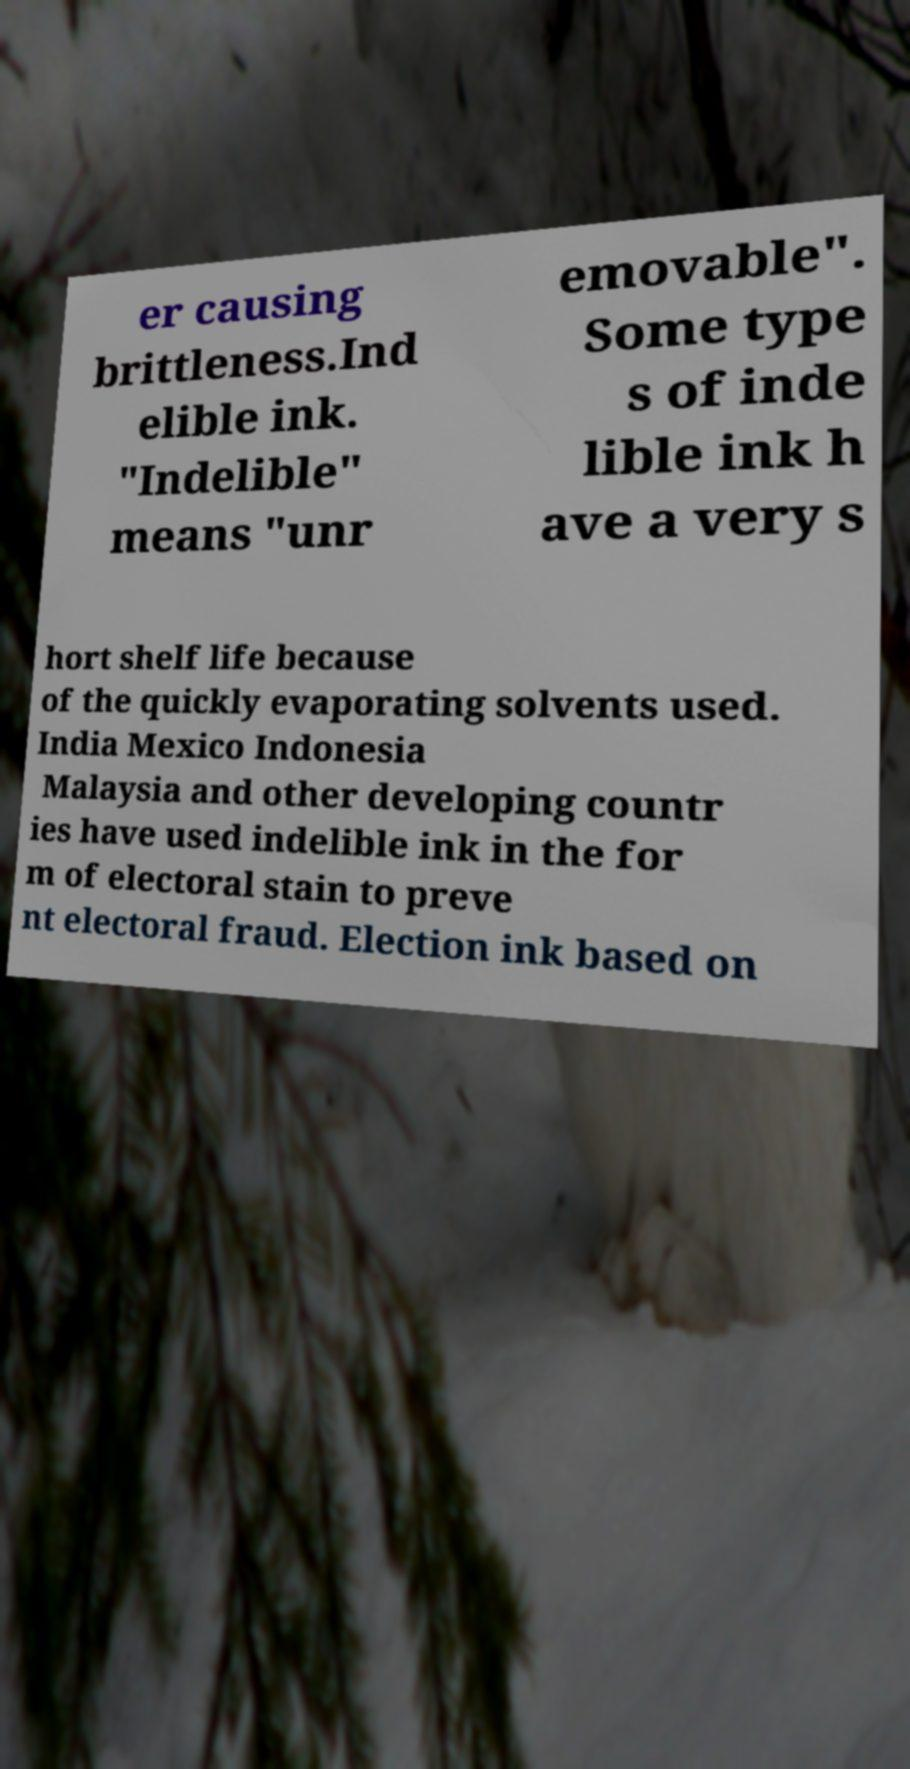Can you accurately transcribe the text from the provided image for me? er causing brittleness.Ind elible ink. "Indelible" means "unr emovable". Some type s of inde lible ink h ave a very s hort shelf life because of the quickly evaporating solvents used. India Mexico Indonesia Malaysia and other developing countr ies have used indelible ink in the for m of electoral stain to preve nt electoral fraud. Election ink based on 